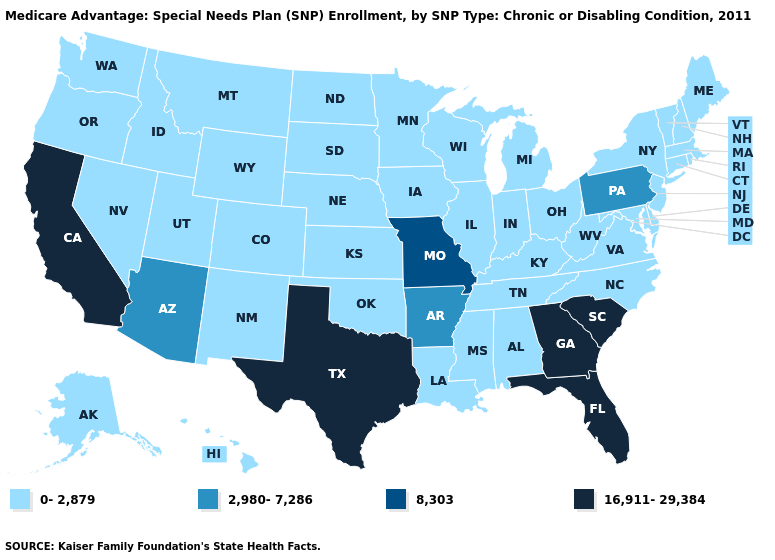Which states hav the highest value in the MidWest?
Keep it brief. Missouri. Does Nebraska have the highest value in the MidWest?
Give a very brief answer. No. What is the lowest value in states that border Georgia?
Be succinct. 0-2,879. What is the value of Wisconsin?
Keep it brief. 0-2,879. What is the value of North Dakota?
Concise answer only. 0-2,879. Does the map have missing data?
Short answer required. No. What is the value of Delaware?
Give a very brief answer. 0-2,879. Among the states that border Utah , does Arizona have the lowest value?
Quick response, please. No. Name the states that have a value in the range 2,980-7,286?
Answer briefly. Arkansas, Arizona, Pennsylvania. Among the states that border Oklahoma , which have the lowest value?
Write a very short answer. Colorado, Kansas, New Mexico. Is the legend a continuous bar?
Answer briefly. No. Does Oregon have the same value as Wyoming?
Short answer required. Yes. Does Vermont have the same value as Texas?
Be succinct. No. Among the states that border Georgia , does Tennessee have the lowest value?
Give a very brief answer. Yes. 